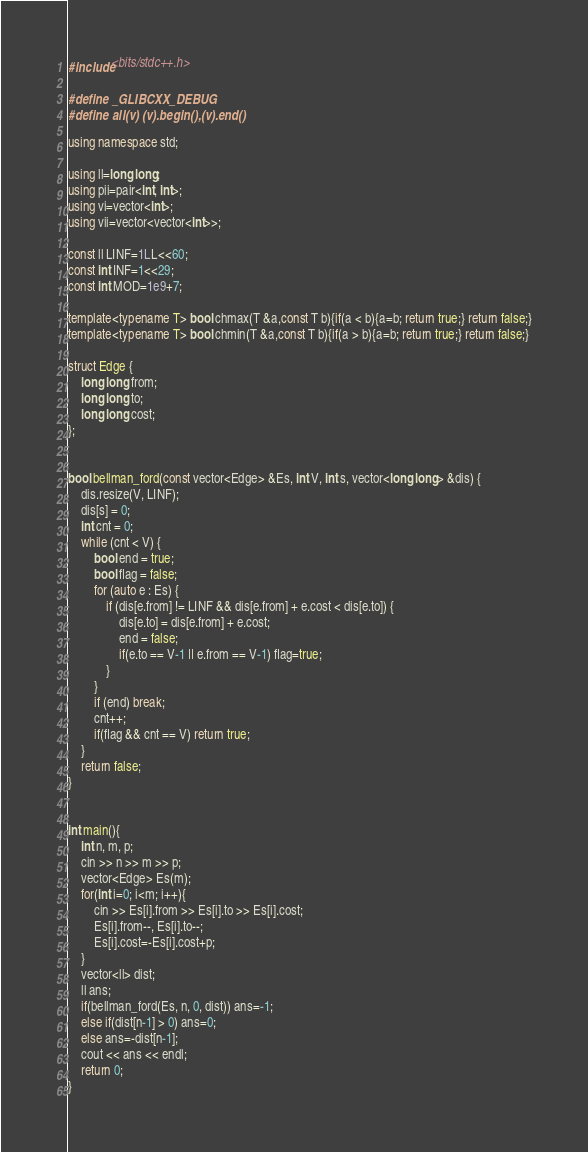Convert code to text. <code><loc_0><loc_0><loc_500><loc_500><_C++_>#include<bits/stdc++.h>

#define _GLIBCXX_DEBUG
#define all(v) (v).begin(),(v).end()

using namespace std;

using ll=long long;
using pii=pair<int, int>;
using vi=vector<int>;
using vii=vector<vector<int>>;

const ll LINF=1LL<<60;
const int INF=1<<29;
const int MOD=1e9+7;

template<typename T> bool chmax(T &a,const T b){if(a < b){a=b; return true;} return false;}
template<typename T> bool chmin(T &a,const T b){if(a > b){a=b; return true;} return false;}

struct Edge {
    long long from;
    long long to;
    long long cost;
};
 

bool bellman_ford(const vector<Edge> &Es, int V, int s, vector<long long> &dis) {
    dis.resize(V, LINF);
    dis[s] = 0;
    int cnt = 0;
    while (cnt < V) {
        bool end = true;
        bool flag = false;
        for (auto e : Es) {
            if (dis[e.from] != LINF && dis[e.from] + e.cost < dis[e.to]) {
                dis[e.to] = dis[e.from] + e.cost;
                end = false;
                if(e.to == V-1 || e.from == V-1) flag=true;
            }
        }
        if (end) break;
        cnt++;
        if(flag && cnt == V) return true;
    }
    return false;
}


int main(){
    int n, m, p;
    cin >> n >> m >> p;
    vector<Edge> Es(m);
    for(int i=0; i<m; i++){
        cin >> Es[i].from >> Es[i].to >> Es[i].cost;
        Es[i].from--, Es[i].to--;
        Es[i].cost=-Es[i].cost+p;
    }
    vector<ll> dist;
    ll ans;
    if(bellman_ford(Es, n, 0, dist)) ans=-1;
    else if(dist[n-1] > 0) ans=0;
    else ans=-dist[n-1];
    cout << ans << endl;
    return 0;
}</code> 